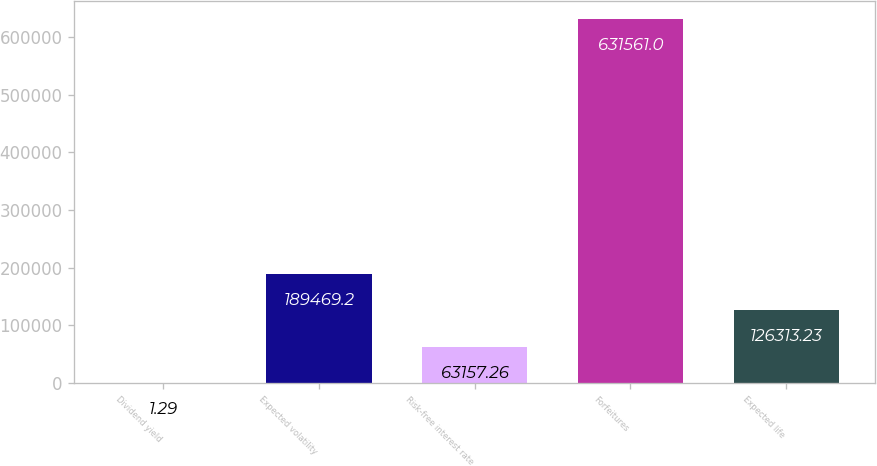Convert chart to OTSL. <chart><loc_0><loc_0><loc_500><loc_500><bar_chart><fcel>Dividend yield<fcel>Expected volatility<fcel>Risk-free interest rate<fcel>Forfeitures<fcel>Expected life<nl><fcel>1.29<fcel>189469<fcel>63157.3<fcel>631561<fcel>126313<nl></chart> 